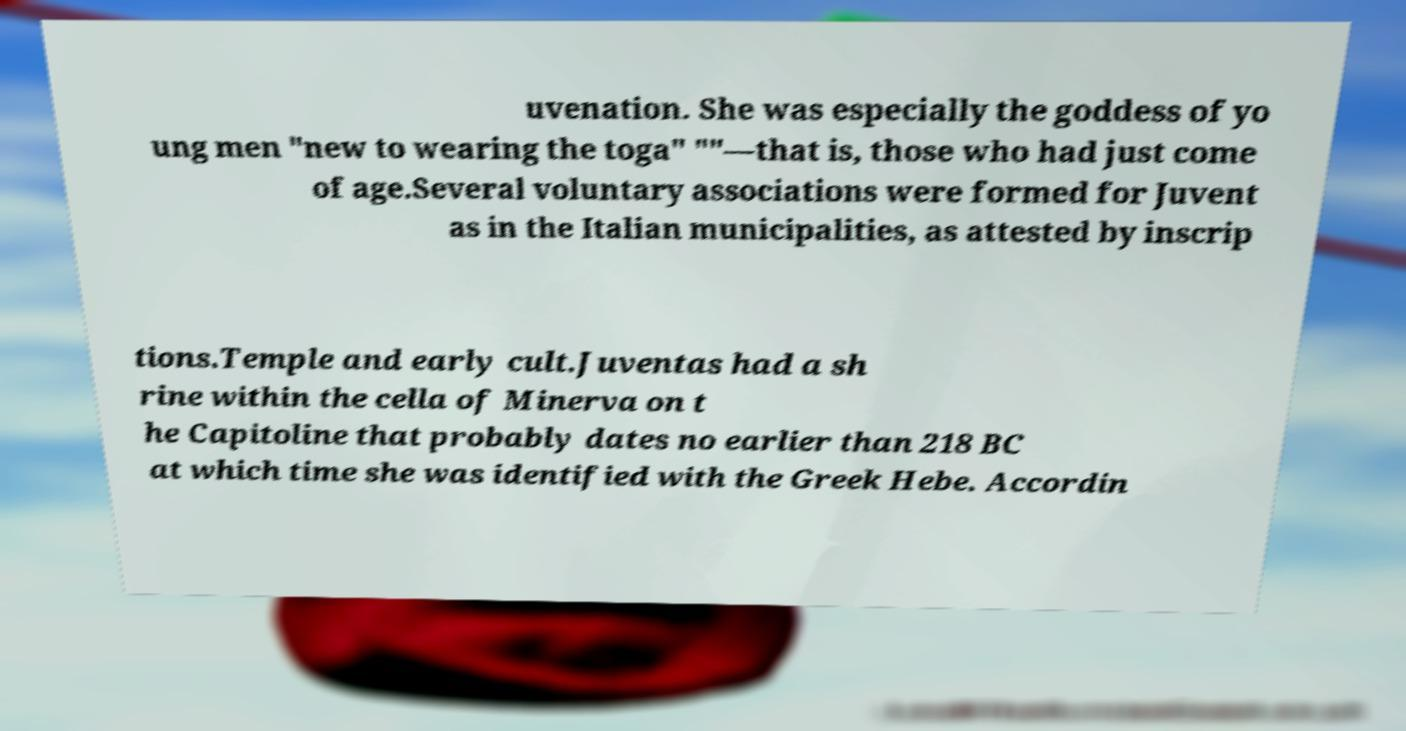Could you assist in decoding the text presented in this image and type it out clearly? uvenation. She was especially the goddess of yo ung men "new to wearing the toga" ""—that is, those who had just come of age.Several voluntary associations were formed for Juvent as in the Italian municipalities, as attested by inscrip tions.Temple and early cult.Juventas had a sh rine within the cella of Minerva on t he Capitoline that probably dates no earlier than 218 BC at which time she was identified with the Greek Hebe. Accordin 